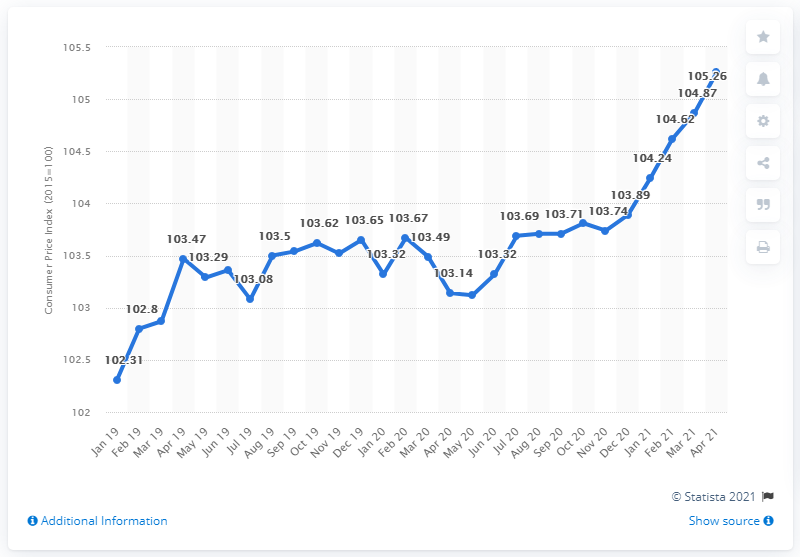Draw attention to some important aspects in this diagram. In April 2021, the Consumer Price Index (CPI) was 105.26. 